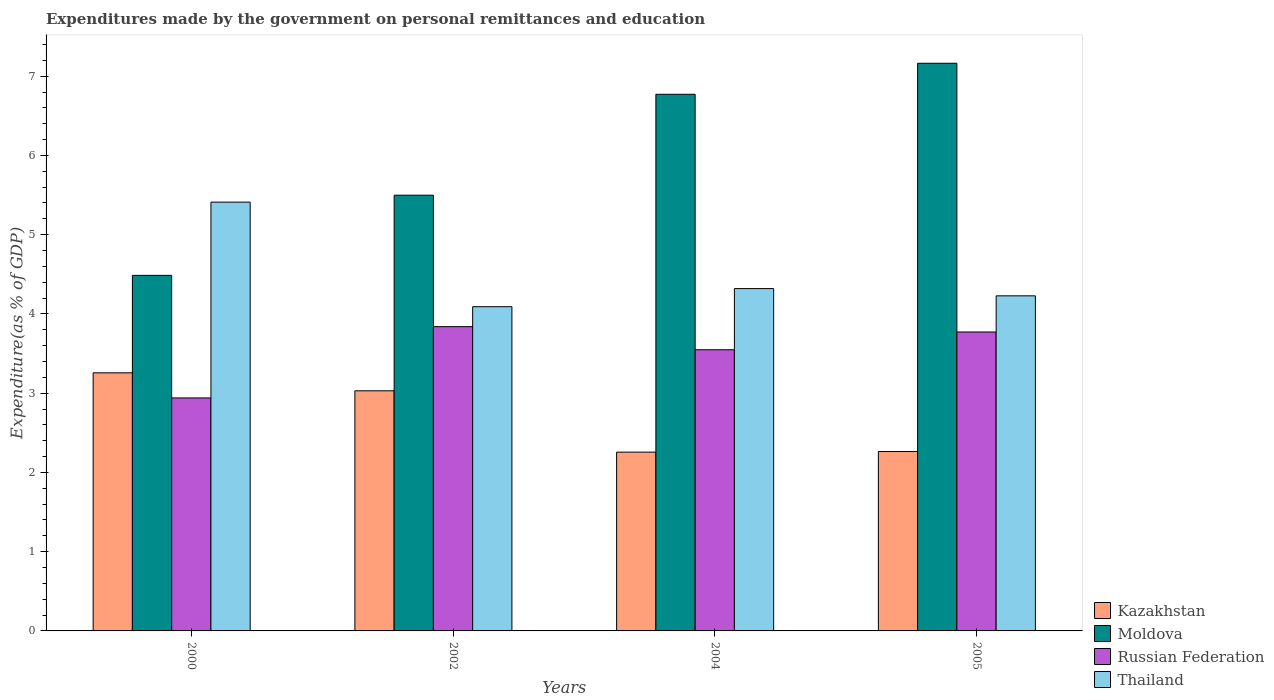How many groups of bars are there?
Give a very brief answer. 4. Are the number of bars per tick equal to the number of legend labels?
Make the answer very short. Yes. Are the number of bars on each tick of the X-axis equal?
Offer a very short reply. Yes. What is the expenditures made by the government on personal remittances and education in Kazakhstan in 2004?
Offer a very short reply. 2.26. Across all years, what is the maximum expenditures made by the government on personal remittances and education in Russian Federation?
Provide a succinct answer. 3.84. Across all years, what is the minimum expenditures made by the government on personal remittances and education in Russian Federation?
Give a very brief answer. 2.94. In which year was the expenditures made by the government on personal remittances and education in Moldova minimum?
Provide a short and direct response. 2000. What is the total expenditures made by the government on personal remittances and education in Moldova in the graph?
Give a very brief answer. 23.92. What is the difference between the expenditures made by the government on personal remittances and education in Russian Federation in 2000 and that in 2004?
Offer a terse response. -0.61. What is the difference between the expenditures made by the government on personal remittances and education in Kazakhstan in 2005 and the expenditures made by the government on personal remittances and education in Thailand in 2004?
Keep it short and to the point. -2.06. What is the average expenditures made by the government on personal remittances and education in Thailand per year?
Offer a terse response. 4.51. In the year 2002, what is the difference between the expenditures made by the government on personal remittances and education in Russian Federation and expenditures made by the government on personal remittances and education in Kazakhstan?
Offer a terse response. 0.81. In how many years, is the expenditures made by the government on personal remittances and education in Moldova greater than 6.4 %?
Provide a short and direct response. 2. What is the ratio of the expenditures made by the government on personal remittances and education in Moldova in 2002 to that in 2004?
Give a very brief answer. 0.81. Is the expenditures made by the government on personal remittances and education in Kazakhstan in 2002 less than that in 2004?
Provide a short and direct response. No. Is the difference between the expenditures made by the government on personal remittances and education in Russian Federation in 2000 and 2004 greater than the difference between the expenditures made by the government on personal remittances and education in Kazakhstan in 2000 and 2004?
Your answer should be very brief. No. What is the difference between the highest and the second highest expenditures made by the government on personal remittances and education in Thailand?
Your answer should be very brief. 1.09. What is the difference between the highest and the lowest expenditures made by the government on personal remittances and education in Thailand?
Your answer should be compact. 1.32. In how many years, is the expenditures made by the government on personal remittances and education in Kazakhstan greater than the average expenditures made by the government on personal remittances and education in Kazakhstan taken over all years?
Offer a very short reply. 2. Is it the case that in every year, the sum of the expenditures made by the government on personal remittances and education in Moldova and expenditures made by the government on personal remittances and education in Kazakhstan is greater than the sum of expenditures made by the government on personal remittances and education in Russian Federation and expenditures made by the government on personal remittances and education in Thailand?
Ensure brevity in your answer.  Yes. What does the 2nd bar from the left in 2005 represents?
Offer a terse response. Moldova. What does the 3rd bar from the right in 2000 represents?
Make the answer very short. Moldova. Is it the case that in every year, the sum of the expenditures made by the government on personal remittances and education in Kazakhstan and expenditures made by the government on personal remittances and education in Russian Federation is greater than the expenditures made by the government on personal remittances and education in Thailand?
Offer a very short reply. Yes. How many bars are there?
Your answer should be very brief. 16. Are all the bars in the graph horizontal?
Provide a succinct answer. No. How many years are there in the graph?
Make the answer very short. 4. Are the values on the major ticks of Y-axis written in scientific E-notation?
Keep it short and to the point. No. Does the graph contain any zero values?
Your answer should be very brief. No. How many legend labels are there?
Your answer should be very brief. 4. What is the title of the graph?
Your answer should be compact. Expenditures made by the government on personal remittances and education. Does "Gambia, The" appear as one of the legend labels in the graph?
Provide a succinct answer. No. What is the label or title of the X-axis?
Your answer should be very brief. Years. What is the label or title of the Y-axis?
Your response must be concise. Expenditure(as % of GDP). What is the Expenditure(as % of GDP) in Kazakhstan in 2000?
Provide a succinct answer. 3.26. What is the Expenditure(as % of GDP) of Moldova in 2000?
Your answer should be compact. 4.49. What is the Expenditure(as % of GDP) in Russian Federation in 2000?
Your answer should be compact. 2.94. What is the Expenditure(as % of GDP) in Thailand in 2000?
Your answer should be very brief. 5.41. What is the Expenditure(as % of GDP) of Kazakhstan in 2002?
Provide a short and direct response. 3.03. What is the Expenditure(as % of GDP) in Moldova in 2002?
Keep it short and to the point. 5.5. What is the Expenditure(as % of GDP) in Russian Federation in 2002?
Keep it short and to the point. 3.84. What is the Expenditure(as % of GDP) of Thailand in 2002?
Your answer should be very brief. 4.09. What is the Expenditure(as % of GDP) of Kazakhstan in 2004?
Offer a very short reply. 2.26. What is the Expenditure(as % of GDP) in Moldova in 2004?
Your response must be concise. 6.77. What is the Expenditure(as % of GDP) in Russian Federation in 2004?
Your answer should be very brief. 3.55. What is the Expenditure(as % of GDP) of Thailand in 2004?
Offer a terse response. 4.32. What is the Expenditure(as % of GDP) of Kazakhstan in 2005?
Give a very brief answer. 2.26. What is the Expenditure(as % of GDP) in Moldova in 2005?
Ensure brevity in your answer.  7.16. What is the Expenditure(as % of GDP) in Russian Federation in 2005?
Give a very brief answer. 3.77. What is the Expenditure(as % of GDP) of Thailand in 2005?
Keep it short and to the point. 4.23. Across all years, what is the maximum Expenditure(as % of GDP) of Kazakhstan?
Keep it short and to the point. 3.26. Across all years, what is the maximum Expenditure(as % of GDP) of Moldova?
Give a very brief answer. 7.16. Across all years, what is the maximum Expenditure(as % of GDP) in Russian Federation?
Offer a very short reply. 3.84. Across all years, what is the maximum Expenditure(as % of GDP) of Thailand?
Provide a succinct answer. 5.41. Across all years, what is the minimum Expenditure(as % of GDP) of Kazakhstan?
Provide a short and direct response. 2.26. Across all years, what is the minimum Expenditure(as % of GDP) of Moldova?
Ensure brevity in your answer.  4.49. Across all years, what is the minimum Expenditure(as % of GDP) in Russian Federation?
Provide a short and direct response. 2.94. Across all years, what is the minimum Expenditure(as % of GDP) of Thailand?
Make the answer very short. 4.09. What is the total Expenditure(as % of GDP) in Kazakhstan in the graph?
Your answer should be compact. 10.81. What is the total Expenditure(as % of GDP) in Moldova in the graph?
Offer a terse response. 23.92. What is the total Expenditure(as % of GDP) of Russian Federation in the graph?
Give a very brief answer. 14.1. What is the total Expenditure(as % of GDP) in Thailand in the graph?
Ensure brevity in your answer.  18.05. What is the difference between the Expenditure(as % of GDP) of Kazakhstan in 2000 and that in 2002?
Give a very brief answer. 0.23. What is the difference between the Expenditure(as % of GDP) of Moldova in 2000 and that in 2002?
Provide a short and direct response. -1.01. What is the difference between the Expenditure(as % of GDP) in Russian Federation in 2000 and that in 2002?
Ensure brevity in your answer.  -0.9. What is the difference between the Expenditure(as % of GDP) of Thailand in 2000 and that in 2002?
Your answer should be very brief. 1.32. What is the difference between the Expenditure(as % of GDP) in Kazakhstan in 2000 and that in 2004?
Provide a short and direct response. 1. What is the difference between the Expenditure(as % of GDP) of Moldova in 2000 and that in 2004?
Offer a terse response. -2.28. What is the difference between the Expenditure(as % of GDP) of Russian Federation in 2000 and that in 2004?
Ensure brevity in your answer.  -0.61. What is the difference between the Expenditure(as % of GDP) of Thailand in 2000 and that in 2004?
Your response must be concise. 1.09. What is the difference between the Expenditure(as % of GDP) in Moldova in 2000 and that in 2005?
Your answer should be compact. -2.68. What is the difference between the Expenditure(as % of GDP) of Russian Federation in 2000 and that in 2005?
Your answer should be very brief. -0.83. What is the difference between the Expenditure(as % of GDP) in Thailand in 2000 and that in 2005?
Provide a succinct answer. 1.18. What is the difference between the Expenditure(as % of GDP) in Kazakhstan in 2002 and that in 2004?
Give a very brief answer. 0.77. What is the difference between the Expenditure(as % of GDP) in Moldova in 2002 and that in 2004?
Offer a very short reply. -1.27. What is the difference between the Expenditure(as % of GDP) in Russian Federation in 2002 and that in 2004?
Offer a very short reply. 0.29. What is the difference between the Expenditure(as % of GDP) of Thailand in 2002 and that in 2004?
Make the answer very short. -0.23. What is the difference between the Expenditure(as % of GDP) in Kazakhstan in 2002 and that in 2005?
Make the answer very short. 0.77. What is the difference between the Expenditure(as % of GDP) in Moldova in 2002 and that in 2005?
Keep it short and to the point. -1.66. What is the difference between the Expenditure(as % of GDP) of Russian Federation in 2002 and that in 2005?
Provide a short and direct response. 0.07. What is the difference between the Expenditure(as % of GDP) of Thailand in 2002 and that in 2005?
Offer a terse response. -0.14. What is the difference between the Expenditure(as % of GDP) of Kazakhstan in 2004 and that in 2005?
Keep it short and to the point. -0.01. What is the difference between the Expenditure(as % of GDP) of Moldova in 2004 and that in 2005?
Your answer should be very brief. -0.39. What is the difference between the Expenditure(as % of GDP) in Russian Federation in 2004 and that in 2005?
Offer a terse response. -0.22. What is the difference between the Expenditure(as % of GDP) in Thailand in 2004 and that in 2005?
Your response must be concise. 0.09. What is the difference between the Expenditure(as % of GDP) in Kazakhstan in 2000 and the Expenditure(as % of GDP) in Moldova in 2002?
Provide a short and direct response. -2.24. What is the difference between the Expenditure(as % of GDP) in Kazakhstan in 2000 and the Expenditure(as % of GDP) in Russian Federation in 2002?
Your response must be concise. -0.58. What is the difference between the Expenditure(as % of GDP) in Kazakhstan in 2000 and the Expenditure(as % of GDP) in Thailand in 2002?
Your answer should be very brief. -0.83. What is the difference between the Expenditure(as % of GDP) of Moldova in 2000 and the Expenditure(as % of GDP) of Russian Federation in 2002?
Your response must be concise. 0.65. What is the difference between the Expenditure(as % of GDP) in Moldova in 2000 and the Expenditure(as % of GDP) in Thailand in 2002?
Keep it short and to the point. 0.4. What is the difference between the Expenditure(as % of GDP) of Russian Federation in 2000 and the Expenditure(as % of GDP) of Thailand in 2002?
Your response must be concise. -1.15. What is the difference between the Expenditure(as % of GDP) in Kazakhstan in 2000 and the Expenditure(as % of GDP) in Moldova in 2004?
Ensure brevity in your answer.  -3.51. What is the difference between the Expenditure(as % of GDP) of Kazakhstan in 2000 and the Expenditure(as % of GDP) of Russian Federation in 2004?
Ensure brevity in your answer.  -0.29. What is the difference between the Expenditure(as % of GDP) in Kazakhstan in 2000 and the Expenditure(as % of GDP) in Thailand in 2004?
Give a very brief answer. -1.06. What is the difference between the Expenditure(as % of GDP) in Moldova in 2000 and the Expenditure(as % of GDP) in Russian Federation in 2004?
Ensure brevity in your answer.  0.94. What is the difference between the Expenditure(as % of GDP) of Moldova in 2000 and the Expenditure(as % of GDP) of Thailand in 2004?
Offer a terse response. 0.17. What is the difference between the Expenditure(as % of GDP) of Russian Federation in 2000 and the Expenditure(as % of GDP) of Thailand in 2004?
Your response must be concise. -1.38. What is the difference between the Expenditure(as % of GDP) in Kazakhstan in 2000 and the Expenditure(as % of GDP) in Moldova in 2005?
Offer a terse response. -3.91. What is the difference between the Expenditure(as % of GDP) in Kazakhstan in 2000 and the Expenditure(as % of GDP) in Russian Federation in 2005?
Offer a very short reply. -0.52. What is the difference between the Expenditure(as % of GDP) in Kazakhstan in 2000 and the Expenditure(as % of GDP) in Thailand in 2005?
Provide a succinct answer. -0.97. What is the difference between the Expenditure(as % of GDP) in Moldova in 2000 and the Expenditure(as % of GDP) in Russian Federation in 2005?
Ensure brevity in your answer.  0.71. What is the difference between the Expenditure(as % of GDP) in Moldova in 2000 and the Expenditure(as % of GDP) in Thailand in 2005?
Ensure brevity in your answer.  0.26. What is the difference between the Expenditure(as % of GDP) in Russian Federation in 2000 and the Expenditure(as % of GDP) in Thailand in 2005?
Give a very brief answer. -1.29. What is the difference between the Expenditure(as % of GDP) of Kazakhstan in 2002 and the Expenditure(as % of GDP) of Moldova in 2004?
Offer a very short reply. -3.74. What is the difference between the Expenditure(as % of GDP) in Kazakhstan in 2002 and the Expenditure(as % of GDP) in Russian Federation in 2004?
Provide a short and direct response. -0.52. What is the difference between the Expenditure(as % of GDP) in Kazakhstan in 2002 and the Expenditure(as % of GDP) in Thailand in 2004?
Offer a terse response. -1.29. What is the difference between the Expenditure(as % of GDP) in Moldova in 2002 and the Expenditure(as % of GDP) in Russian Federation in 2004?
Provide a succinct answer. 1.95. What is the difference between the Expenditure(as % of GDP) in Moldova in 2002 and the Expenditure(as % of GDP) in Thailand in 2004?
Offer a terse response. 1.18. What is the difference between the Expenditure(as % of GDP) in Russian Federation in 2002 and the Expenditure(as % of GDP) in Thailand in 2004?
Ensure brevity in your answer.  -0.48. What is the difference between the Expenditure(as % of GDP) of Kazakhstan in 2002 and the Expenditure(as % of GDP) of Moldova in 2005?
Offer a very short reply. -4.13. What is the difference between the Expenditure(as % of GDP) in Kazakhstan in 2002 and the Expenditure(as % of GDP) in Russian Federation in 2005?
Offer a very short reply. -0.74. What is the difference between the Expenditure(as % of GDP) in Kazakhstan in 2002 and the Expenditure(as % of GDP) in Thailand in 2005?
Your response must be concise. -1.2. What is the difference between the Expenditure(as % of GDP) of Moldova in 2002 and the Expenditure(as % of GDP) of Russian Federation in 2005?
Make the answer very short. 1.73. What is the difference between the Expenditure(as % of GDP) of Moldova in 2002 and the Expenditure(as % of GDP) of Thailand in 2005?
Your response must be concise. 1.27. What is the difference between the Expenditure(as % of GDP) of Russian Federation in 2002 and the Expenditure(as % of GDP) of Thailand in 2005?
Provide a short and direct response. -0.39. What is the difference between the Expenditure(as % of GDP) of Kazakhstan in 2004 and the Expenditure(as % of GDP) of Moldova in 2005?
Your response must be concise. -4.91. What is the difference between the Expenditure(as % of GDP) of Kazakhstan in 2004 and the Expenditure(as % of GDP) of Russian Federation in 2005?
Your response must be concise. -1.52. What is the difference between the Expenditure(as % of GDP) of Kazakhstan in 2004 and the Expenditure(as % of GDP) of Thailand in 2005?
Provide a succinct answer. -1.97. What is the difference between the Expenditure(as % of GDP) of Moldova in 2004 and the Expenditure(as % of GDP) of Russian Federation in 2005?
Make the answer very short. 3. What is the difference between the Expenditure(as % of GDP) of Moldova in 2004 and the Expenditure(as % of GDP) of Thailand in 2005?
Give a very brief answer. 2.54. What is the difference between the Expenditure(as % of GDP) of Russian Federation in 2004 and the Expenditure(as % of GDP) of Thailand in 2005?
Your answer should be compact. -0.68. What is the average Expenditure(as % of GDP) in Kazakhstan per year?
Your answer should be compact. 2.7. What is the average Expenditure(as % of GDP) of Moldova per year?
Make the answer very short. 5.98. What is the average Expenditure(as % of GDP) in Russian Federation per year?
Provide a short and direct response. 3.52. What is the average Expenditure(as % of GDP) in Thailand per year?
Provide a succinct answer. 4.51. In the year 2000, what is the difference between the Expenditure(as % of GDP) in Kazakhstan and Expenditure(as % of GDP) in Moldova?
Ensure brevity in your answer.  -1.23. In the year 2000, what is the difference between the Expenditure(as % of GDP) of Kazakhstan and Expenditure(as % of GDP) of Russian Federation?
Provide a succinct answer. 0.32. In the year 2000, what is the difference between the Expenditure(as % of GDP) in Kazakhstan and Expenditure(as % of GDP) in Thailand?
Provide a short and direct response. -2.15. In the year 2000, what is the difference between the Expenditure(as % of GDP) in Moldova and Expenditure(as % of GDP) in Russian Federation?
Your answer should be very brief. 1.55. In the year 2000, what is the difference between the Expenditure(as % of GDP) of Moldova and Expenditure(as % of GDP) of Thailand?
Your answer should be very brief. -0.92. In the year 2000, what is the difference between the Expenditure(as % of GDP) of Russian Federation and Expenditure(as % of GDP) of Thailand?
Offer a terse response. -2.47. In the year 2002, what is the difference between the Expenditure(as % of GDP) in Kazakhstan and Expenditure(as % of GDP) in Moldova?
Your response must be concise. -2.47. In the year 2002, what is the difference between the Expenditure(as % of GDP) in Kazakhstan and Expenditure(as % of GDP) in Russian Federation?
Keep it short and to the point. -0.81. In the year 2002, what is the difference between the Expenditure(as % of GDP) of Kazakhstan and Expenditure(as % of GDP) of Thailand?
Provide a short and direct response. -1.06. In the year 2002, what is the difference between the Expenditure(as % of GDP) of Moldova and Expenditure(as % of GDP) of Russian Federation?
Your answer should be very brief. 1.66. In the year 2002, what is the difference between the Expenditure(as % of GDP) of Moldova and Expenditure(as % of GDP) of Thailand?
Make the answer very short. 1.41. In the year 2002, what is the difference between the Expenditure(as % of GDP) of Russian Federation and Expenditure(as % of GDP) of Thailand?
Give a very brief answer. -0.25. In the year 2004, what is the difference between the Expenditure(as % of GDP) in Kazakhstan and Expenditure(as % of GDP) in Moldova?
Your answer should be compact. -4.52. In the year 2004, what is the difference between the Expenditure(as % of GDP) of Kazakhstan and Expenditure(as % of GDP) of Russian Federation?
Give a very brief answer. -1.29. In the year 2004, what is the difference between the Expenditure(as % of GDP) of Kazakhstan and Expenditure(as % of GDP) of Thailand?
Your answer should be very brief. -2.06. In the year 2004, what is the difference between the Expenditure(as % of GDP) in Moldova and Expenditure(as % of GDP) in Russian Federation?
Keep it short and to the point. 3.22. In the year 2004, what is the difference between the Expenditure(as % of GDP) of Moldova and Expenditure(as % of GDP) of Thailand?
Keep it short and to the point. 2.45. In the year 2004, what is the difference between the Expenditure(as % of GDP) of Russian Federation and Expenditure(as % of GDP) of Thailand?
Make the answer very short. -0.77. In the year 2005, what is the difference between the Expenditure(as % of GDP) of Kazakhstan and Expenditure(as % of GDP) of Moldova?
Give a very brief answer. -4.9. In the year 2005, what is the difference between the Expenditure(as % of GDP) in Kazakhstan and Expenditure(as % of GDP) in Russian Federation?
Provide a succinct answer. -1.51. In the year 2005, what is the difference between the Expenditure(as % of GDP) of Kazakhstan and Expenditure(as % of GDP) of Thailand?
Your response must be concise. -1.96. In the year 2005, what is the difference between the Expenditure(as % of GDP) of Moldova and Expenditure(as % of GDP) of Russian Federation?
Your answer should be very brief. 3.39. In the year 2005, what is the difference between the Expenditure(as % of GDP) in Moldova and Expenditure(as % of GDP) in Thailand?
Provide a succinct answer. 2.93. In the year 2005, what is the difference between the Expenditure(as % of GDP) of Russian Federation and Expenditure(as % of GDP) of Thailand?
Provide a succinct answer. -0.46. What is the ratio of the Expenditure(as % of GDP) of Kazakhstan in 2000 to that in 2002?
Your answer should be compact. 1.07. What is the ratio of the Expenditure(as % of GDP) in Moldova in 2000 to that in 2002?
Provide a short and direct response. 0.82. What is the ratio of the Expenditure(as % of GDP) in Russian Federation in 2000 to that in 2002?
Your answer should be compact. 0.77. What is the ratio of the Expenditure(as % of GDP) in Thailand in 2000 to that in 2002?
Provide a succinct answer. 1.32. What is the ratio of the Expenditure(as % of GDP) of Kazakhstan in 2000 to that in 2004?
Offer a terse response. 1.44. What is the ratio of the Expenditure(as % of GDP) of Moldova in 2000 to that in 2004?
Give a very brief answer. 0.66. What is the ratio of the Expenditure(as % of GDP) in Russian Federation in 2000 to that in 2004?
Your answer should be compact. 0.83. What is the ratio of the Expenditure(as % of GDP) in Thailand in 2000 to that in 2004?
Keep it short and to the point. 1.25. What is the ratio of the Expenditure(as % of GDP) of Kazakhstan in 2000 to that in 2005?
Make the answer very short. 1.44. What is the ratio of the Expenditure(as % of GDP) of Moldova in 2000 to that in 2005?
Your answer should be very brief. 0.63. What is the ratio of the Expenditure(as % of GDP) in Russian Federation in 2000 to that in 2005?
Make the answer very short. 0.78. What is the ratio of the Expenditure(as % of GDP) of Thailand in 2000 to that in 2005?
Offer a terse response. 1.28. What is the ratio of the Expenditure(as % of GDP) of Kazakhstan in 2002 to that in 2004?
Provide a short and direct response. 1.34. What is the ratio of the Expenditure(as % of GDP) in Moldova in 2002 to that in 2004?
Keep it short and to the point. 0.81. What is the ratio of the Expenditure(as % of GDP) of Russian Federation in 2002 to that in 2004?
Your answer should be very brief. 1.08. What is the ratio of the Expenditure(as % of GDP) of Thailand in 2002 to that in 2004?
Keep it short and to the point. 0.95. What is the ratio of the Expenditure(as % of GDP) in Kazakhstan in 2002 to that in 2005?
Give a very brief answer. 1.34. What is the ratio of the Expenditure(as % of GDP) in Moldova in 2002 to that in 2005?
Your response must be concise. 0.77. What is the ratio of the Expenditure(as % of GDP) of Russian Federation in 2002 to that in 2005?
Provide a short and direct response. 1.02. What is the ratio of the Expenditure(as % of GDP) of Thailand in 2002 to that in 2005?
Provide a succinct answer. 0.97. What is the ratio of the Expenditure(as % of GDP) of Moldova in 2004 to that in 2005?
Provide a succinct answer. 0.95. What is the ratio of the Expenditure(as % of GDP) in Russian Federation in 2004 to that in 2005?
Offer a terse response. 0.94. What is the ratio of the Expenditure(as % of GDP) in Thailand in 2004 to that in 2005?
Keep it short and to the point. 1.02. What is the difference between the highest and the second highest Expenditure(as % of GDP) of Kazakhstan?
Offer a terse response. 0.23. What is the difference between the highest and the second highest Expenditure(as % of GDP) of Moldova?
Provide a short and direct response. 0.39. What is the difference between the highest and the second highest Expenditure(as % of GDP) in Russian Federation?
Offer a terse response. 0.07. What is the difference between the highest and the second highest Expenditure(as % of GDP) in Thailand?
Offer a terse response. 1.09. What is the difference between the highest and the lowest Expenditure(as % of GDP) of Kazakhstan?
Offer a terse response. 1. What is the difference between the highest and the lowest Expenditure(as % of GDP) in Moldova?
Your response must be concise. 2.68. What is the difference between the highest and the lowest Expenditure(as % of GDP) of Russian Federation?
Provide a succinct answer. 0.9. What is the difference between the highest and the lowest Expenditure(as % of GDP) of Thailand?
Keep it short and to the point. 1.32. 